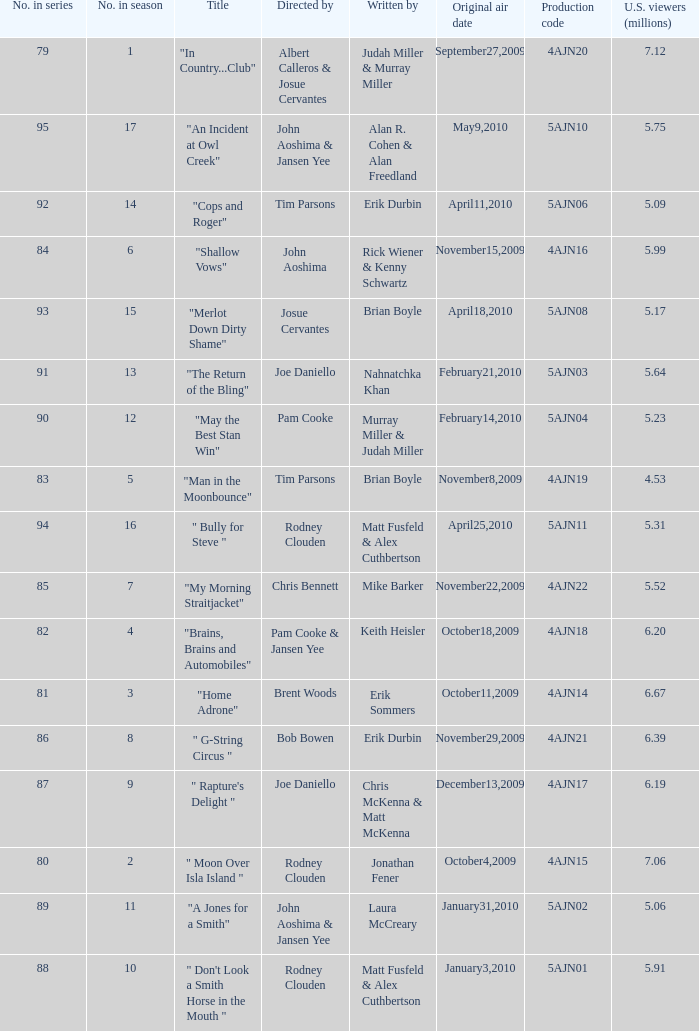Name who wrote the episode directed by  pam cooke & jansen yee Keith Heisler. 